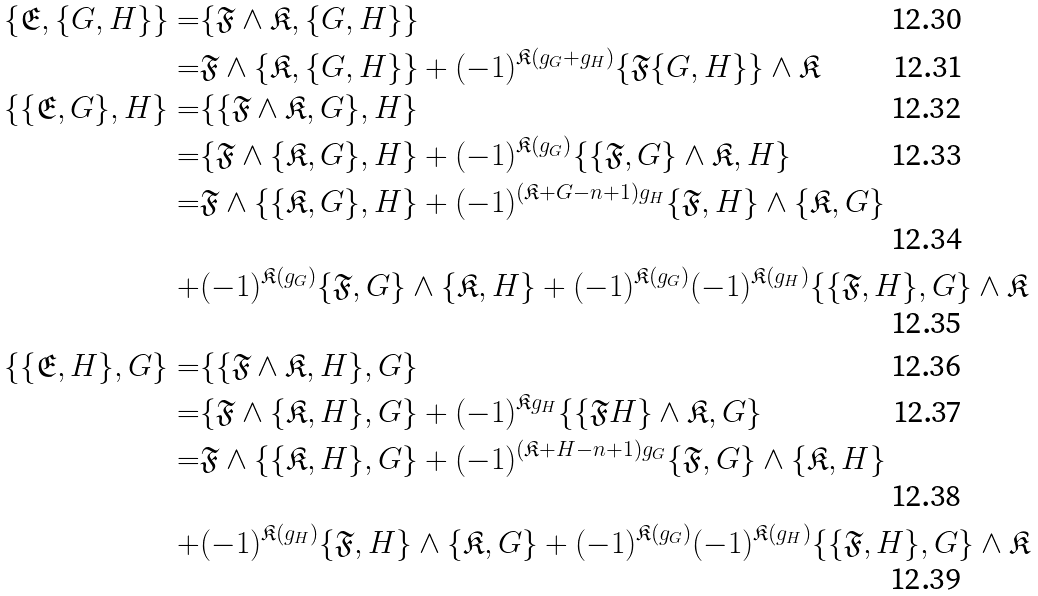<formula> <loc_0><loc_0><loc_500><loc_500>\{ \mathfrak { E } , \{ G , H \} \} = & \{ \mathfrak { F } \wedge \mathfrak { K } , \{ G , H \} \} \\ = & \mathfrak { F } \wedge \{ \mathfrak { K } , \{ G , H \} \} + ( - 1 ) ^ { \mathfrak { K } ( g _ { G } + g _ { H } ) } \{ \mathfrak { F } \{ G , H \} \} \wedge \mathfrak { K } \\ \{ \{ \mathfrak { E } , G \} , H \} = & \{ \{ \mathfrak { F } \wedge \mathfrak { K } , G \} , H \} \\ = & \{ \mathfrak { F } \wedge \{ \mathfrak { K } , G \} , H \} + ( - 1 ) ^ { \mathfrak { K } ( g _ { G } ) } \{ \{ \mathfrak { F } , G \} \wedge \mathfrak { K } , H \} \\ = & \mathfrak { F } \wedge \{ \{ \mathfrak { K } , G \} , H \} + ( - 1 ) ^ { ( \mathfrak { K } + G - n + 1 ) g _ { H } } \{ \mathfrak { F } , H \} \wedge \{ \mathfrak { K } , G \} \\ + & ( - 1 ) ^ { \mathfrak { K } ( g _ { G } ) } \{ \mathfrak { F } , G \} \wedge \{ \mathfrak { K } , H \} + ( - 1 ) ^ { \mathfrak { K } ( g _ { G } ) } ( - 1 ) ^ { \mathfrak { K } ( g _ { H } ) } \{ \{ \mathfrak { F } , H \} , G \} \wedge \mathfrak { K } \\ \{ \{ \mathfrak { E } , H \} , G \} = & \{ \{ \mathfrak { F } \wedge \mathfrak { K } , H \} , G \} \\ = & \{ \mathfrak { F } \wedge \{ \mathfrak { K } , H \} , G \} + ( - 1 ) ^ { \mathfrak { K } g _ { H } } \{ \{ \mathfrak { F } H \} \wedge \mathfrak { K } , G \} \\ = & \mathfrak { F } \wedge \{ \{ \mathfrak { K } , H \} , G \} + ( - 1 ) ^ { ( \mathfrak { K } + H - n + 1 ) g _ { G } } \{ \mathfrak { F } , G \} \wedge \{ \mathfrak { K } , H \} \\ + & ( - 1 ) ^ { \mathfrak { K } ( g _ { H } ) } \{ \mathfrak { F } , H \} \wedge \{ \mathfrak { K } , G \} + ( - 1 ) ^ { \mathfrak { K } ( g _ { G } ) } ( - 1 ) ^ { \mathfrak { K } ( g _ { H } ) } \{ \{ \mathfrak { F } , H \} , G \} \wedge \mathfrak { K }</formula> 